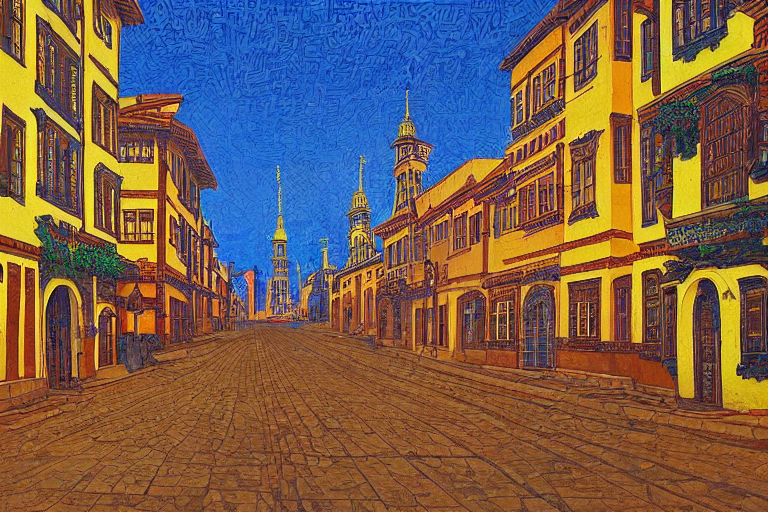What time of day or season could this image be representing, based on the lighting and environment? The sharp shadows and the brightness of the image hint at a scene set during the daytime, potentially early morning or late afternoon when shadows are more pronounced. The clear sky suggests a fair weather season, possibly spring or summer, considering the overall warmth of the colors and the liveliness they impart to the scene. Do the architectural elements in the image reflect a particular historical period or cultural setting? Yes, the architecture carries elements reminiscent of traditional European styles, possibly Baroque or Renaissance, suggested by the ornate facades and the presence of what appear to be church spires in the distance. These details might indicate a setting steeped in history, likely emulating a town or city center common in European countries. 